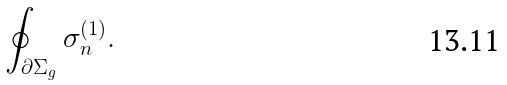Convert formula to latex. <formula><loc_0><loc_0><loc_500><loc_500>\oint _ { \partial \Sigma _ { g } } \sigma _ { n } ^ { ( 1 ) } .</formula> 